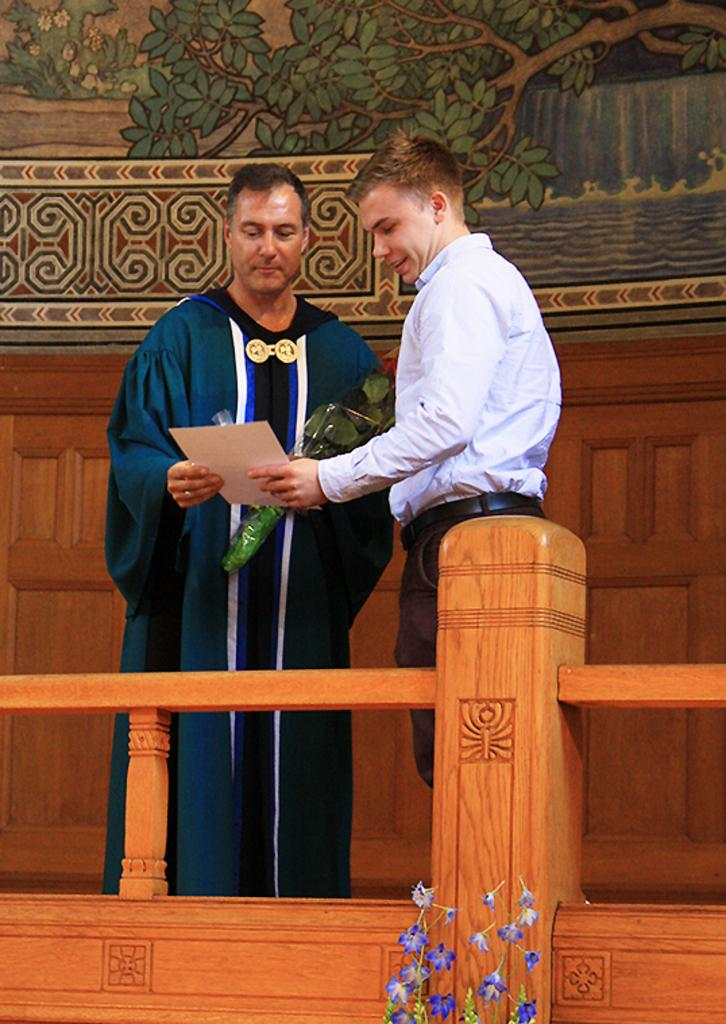How many people are in the image? There are two men in the image. What are the men doing in the image? The men are standing in the image. What are the men holding in their hands? The men are holding objects in their hands. What can be seen on the wall in the background of the image? There is a painting on the wall in the background of the image. What type of underwear is the man on the left wearing in the image? There is no information about the men's clothing in the image, so it cannot be determined what type of underwear the man on the left is wearing. 